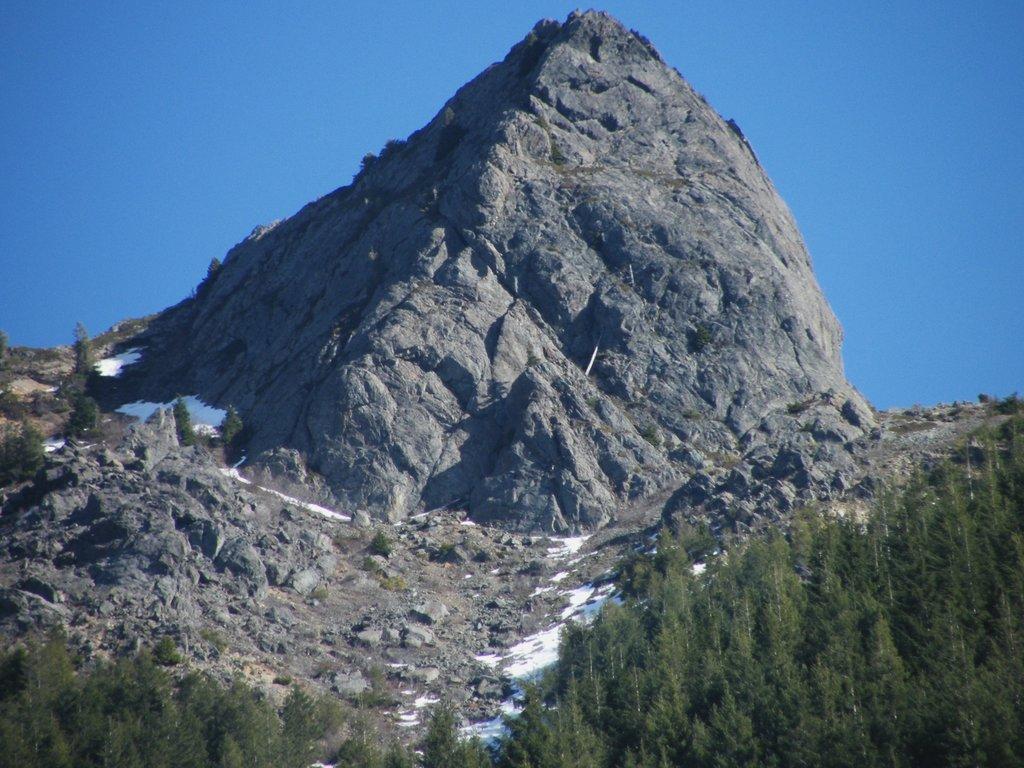Could you give a brief overview of what you see in this image? In this image at the bottom there are some trees and in the center there are some mountains, and rocks and some sand and at the top there is sky. 